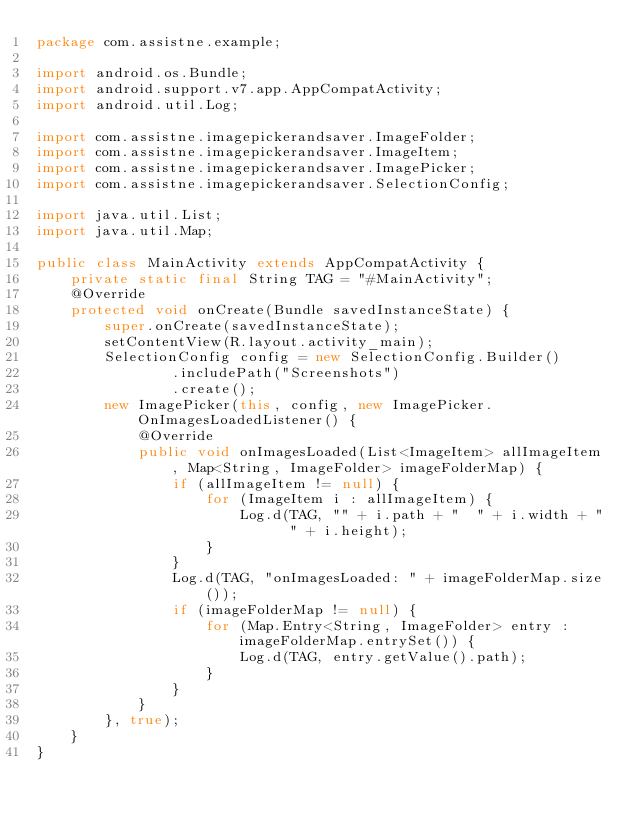Convert code to text. <code><loc_0><loc_0><loc_500><loc_500><_Java_>package com.assistne.example;

import android.os.Bundle;
import android.support.v7.app.AppCompatActivity;
import android.util.Log;

import com.assistne.imagepickerandsaver.ImageFolder;
import com.assistne.imagepickerandsaver.ImageItem;
import com.assistne.imagepickerandsaver.ImagePicker;
import com.assistne.imagepickerandsaver.SelectionConfig;

import java.util.List;
import java.util.Map;

public class MainActivity extends AppCompatActivity {
    private static final String TAG = "#MainActivity";
    @Override
    protected void onCreate(Bundle savedInstanceState) {
        super.onCreate(savedInstanceState);
        setContentView(R.layout.activity_main);
        SelectionConfig config = new SelectionConfig.Builder()
                .includePath("Screenshots")
                .create();
        new ImagePicker(this, config, new ImagePicker.OnImagesLoadedListener() {
            @Override
            public void onImagesLoaded(List<ImageItem> allImageItem, Map<String, ImageFolder> imageFolderMap) {
                if (allImageItem != null) {
                    for (ImageItem i : allImageItem) {
                        Log.d(TAG, "" + i.path + "  " + i.width + "  " + i.height);
                    }
                }
                Log.d(TAG, "onImagesLoaded: " + imageFolderMap.size());
                if (imageFolderMap != null) {
                    for (Map.Entry<String, ImageFolder> entry : imageFolderMap.entrySet()) {
                        Log.d(TAG, entry.getValue().path);
                    }
                }
            }
        }, true);
    }
}
</code> 